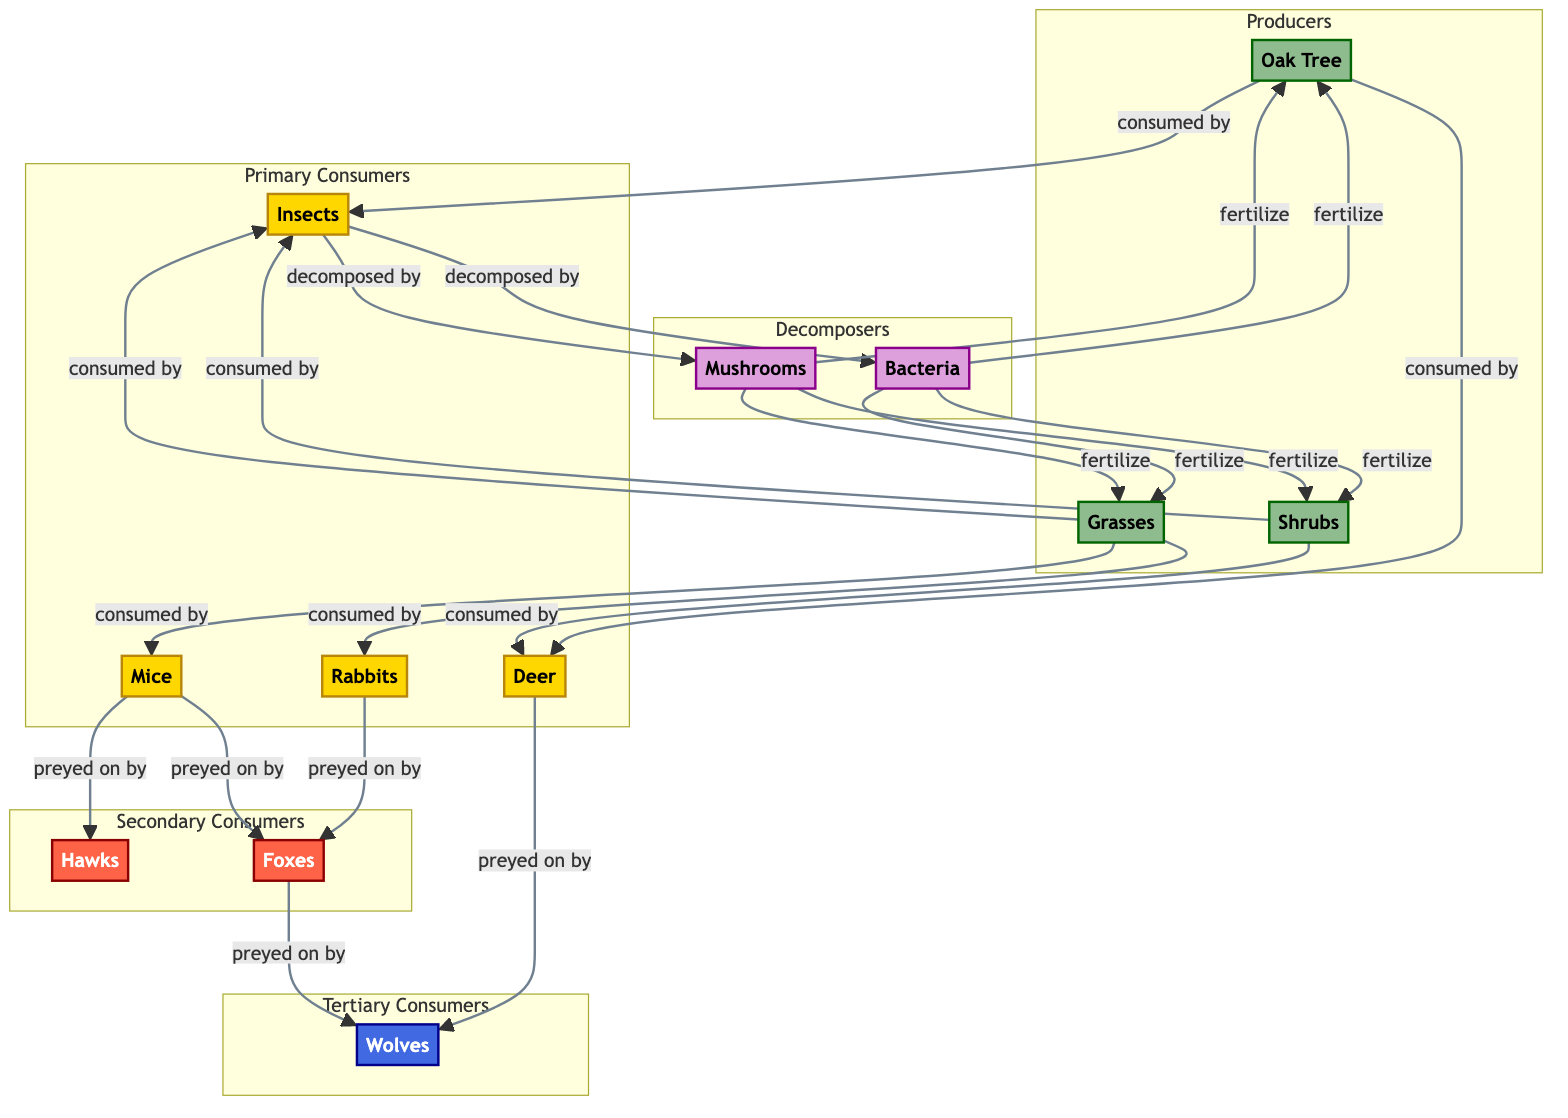What type of organism is an Oak Tree? According to the diagram, an Oak Tree is categorized under Producers, denoted by the green color and the label "producer".
Answer: producer How many primary consumers are represented in the diagram? The diagram lists four primary consumers: Deer, Rabbits, Mice, and Insects, which can be counted directly from the nodes in the Primary Consumers subgraph.
Answer: 4 What is the relationship between Wolves and Foxes in this food web? The diagram illustrates that both Wolves and Foxes are classified as Tertiary and Secondary Consumers respectively, but there is no direct relationship shown between them; they do not have a feeding interaction indicated in the flowchart.
Answer: None Which producers are consumed by Deer? According to the connections in the diagram, Deer are consumed by Oak Trees and Shrubs, as these producers point to Deer in the arrows indicating consumption.
Answer: Oak Tree and Shrubs Who decomposes the Grasses? The diagram specifies that Grasses are consumed by Insects. Following that consumption, Insects are decomposed by Bacteria and Mushrooms, which are classed as decomposers.
Answer: Bacteria and Mushrooms How many total decomposers are shown in the diagram? The diagram depicts two decomposer organisms: Bacteria and Mushrooms, which can be counted from the Decomposers subgraph.
Answer: 2 Which primary consumer preys on Mice? The flowchart indicates that Mice are preyed upon by Hawks, as there is a direct arrow showing the predation relationship from Mice to Hawks in the Secondary Consumers subgraph.
Answer: Hawks What is the relationship between Insects and the grass producers? The relationship is that Insects consume Grasses, as indicated by the arrow in the diagram that shows Grass leading to Insects with the phrase "consumed by".
Answer: consumed by How do decomposers contribute to the ecosystem? The diagram shows that decomposers like Bacteria and Mushrooms break down the waste from primary consumers, which then fertilizes producers, indicating their role in nutrient cycling in the ecosystem.
Answer: fertilize producers 